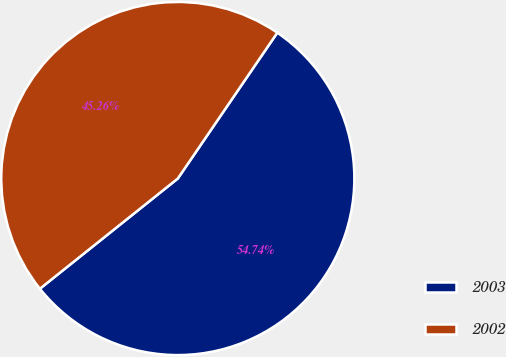Convert chart to OTSL. <chart><loc_0><loc_0><loc_500><loc_500><pie_chart><fcel>2003<fcel>2002<nl><fcel>54.74%<fcel>45.26%<nl></chart> 